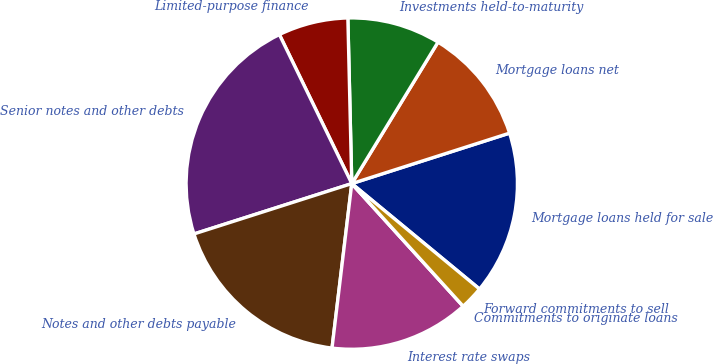Convert chart to OTSL. <chart><loc_0><loc_0><loc_500><loc_500><pie_chart><fcel>Mortgage loans held for sale<fcel>Mortgage loans net<fcel>Investments held-to-maturity<fcel>Limited-purpose finance<fcel>Senior notes and other debts<fcel>Notes and other debts payable<fcel>Interest rate swaps<fcel>Commitments to originate loans<fcel>Forward commitments to sell<nl><fcel>15.91%<fcel>11.36%<fcel>9.09%<fcel>6.82%<fcel>22.72%<fcel>18.18%<fcel>13.64%<fcel>0.0%<fcel>2.28%<nl></chart> 